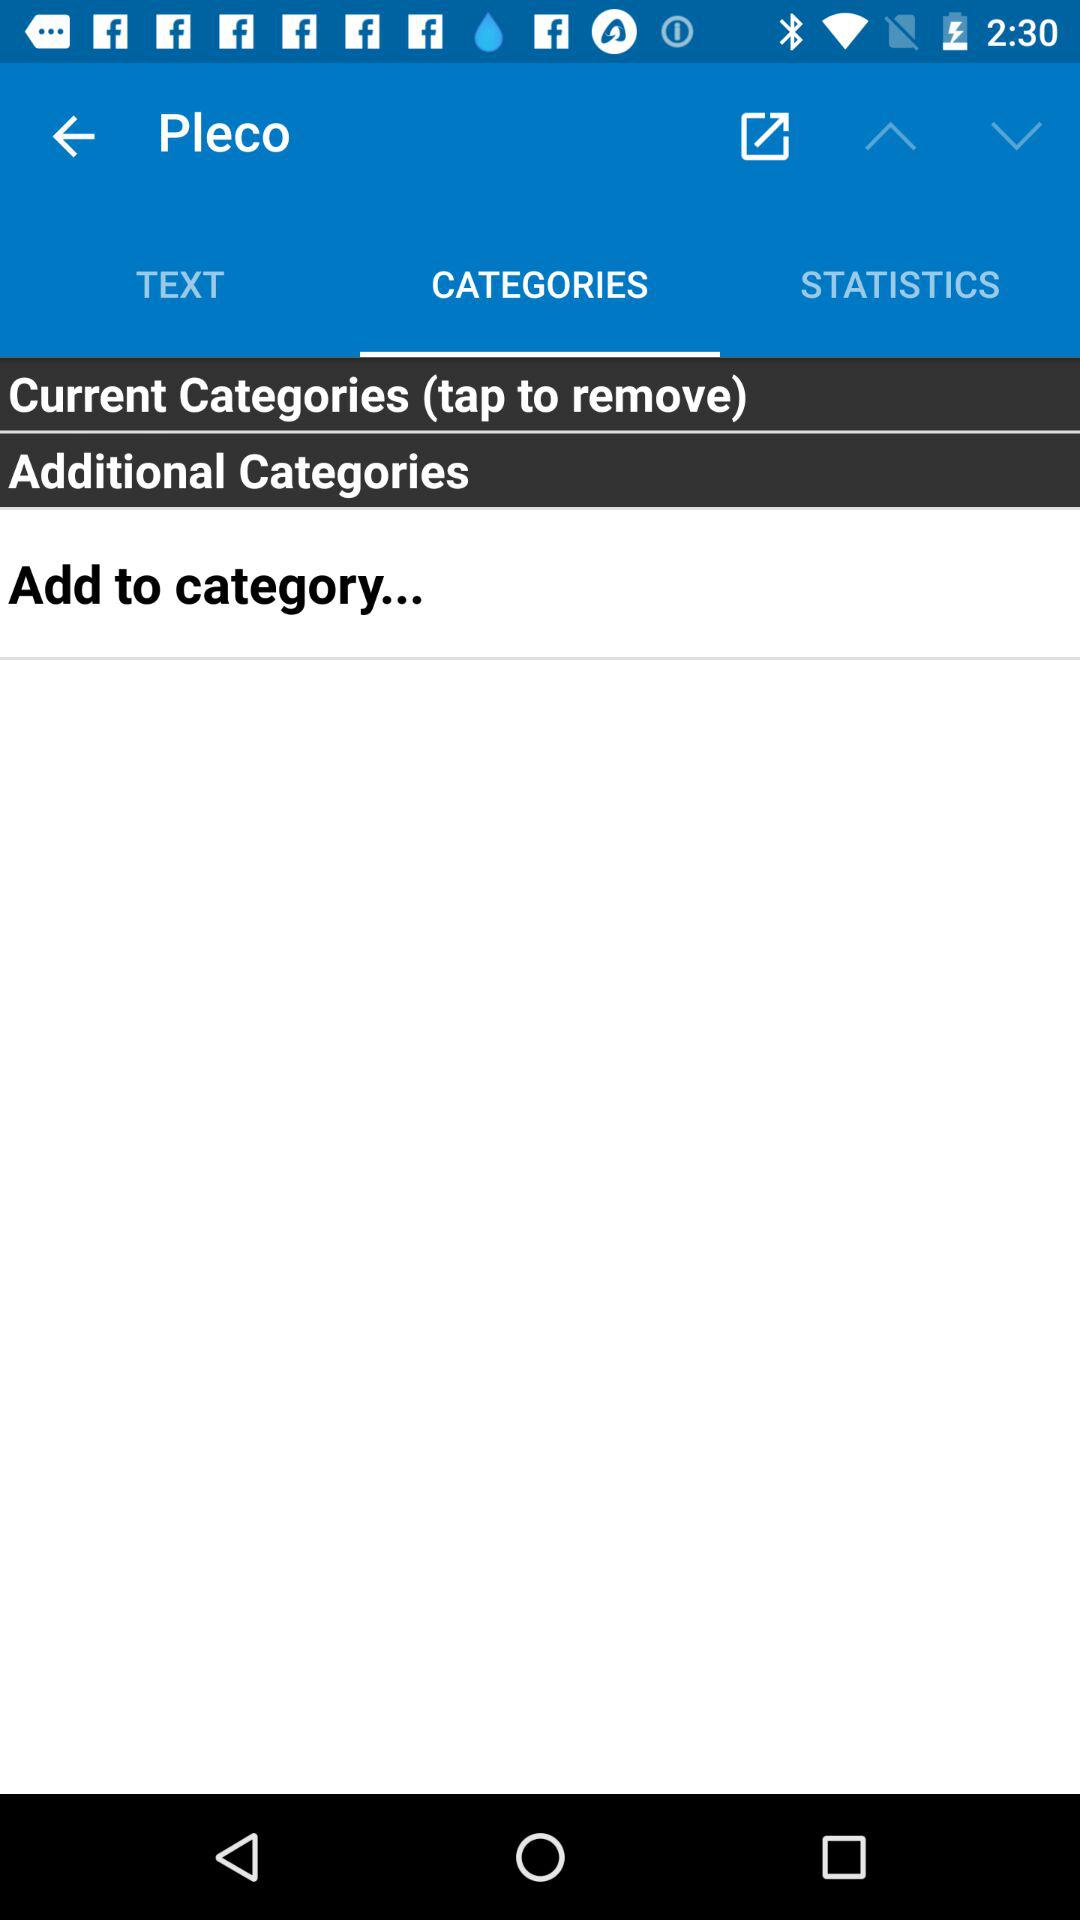Which tab is selected? The selected tab is "CATEGORIES". 